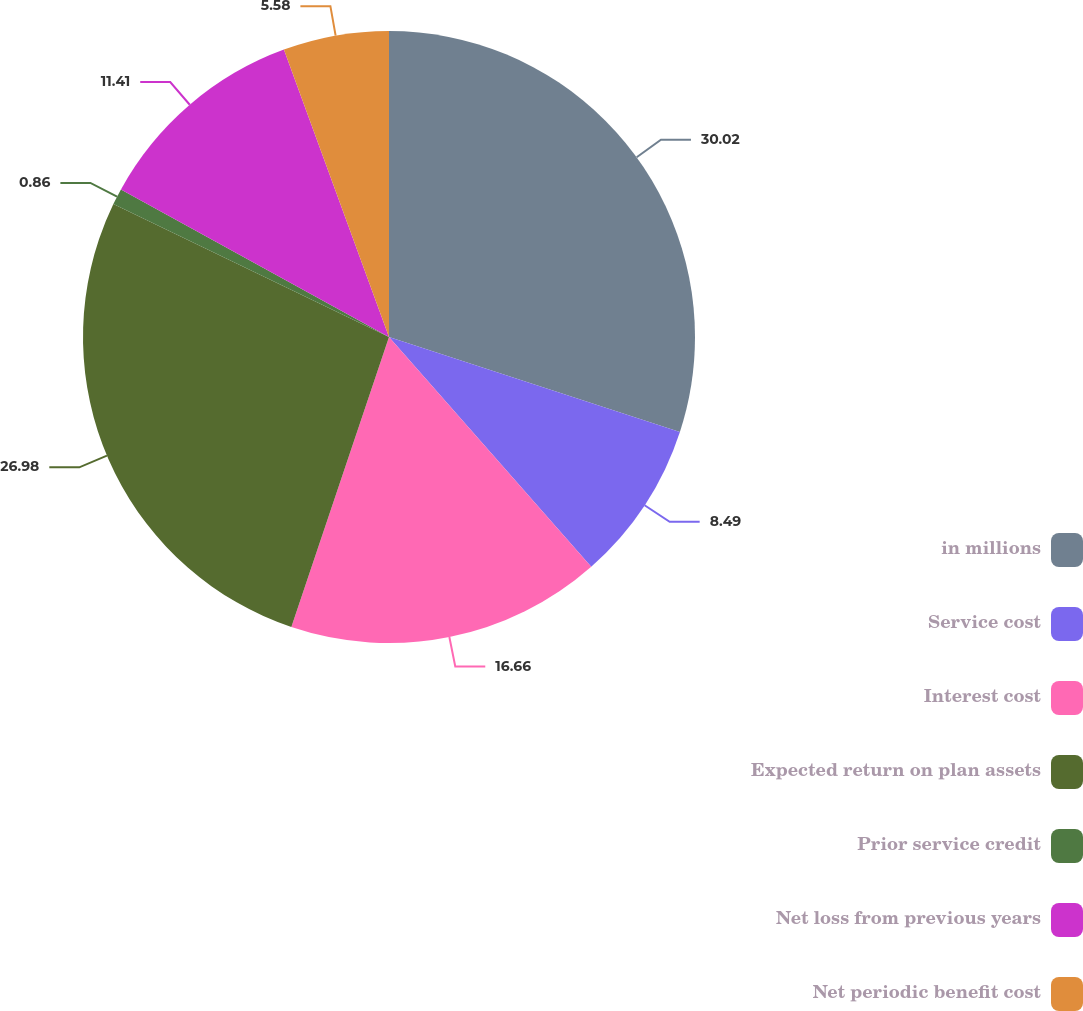Convert chart to OTSL. <chart><loc_0><loc_0><loc_500><loc_500><pie_chart><fcel>in millions<fcel>Service cost<fcel>Interest cost<fcel>Expected return on plan assets<fcel>Prior service credit<fcel>Net loss from previous years<fcel>Net periodic benefit cost<nl><fcel>30.02%<fcel>8.49%<fcel>16.66%<fcel>26.98%<fcel>0.86%<fcel>11.41%<fcel>5.58%<nl></chart> 